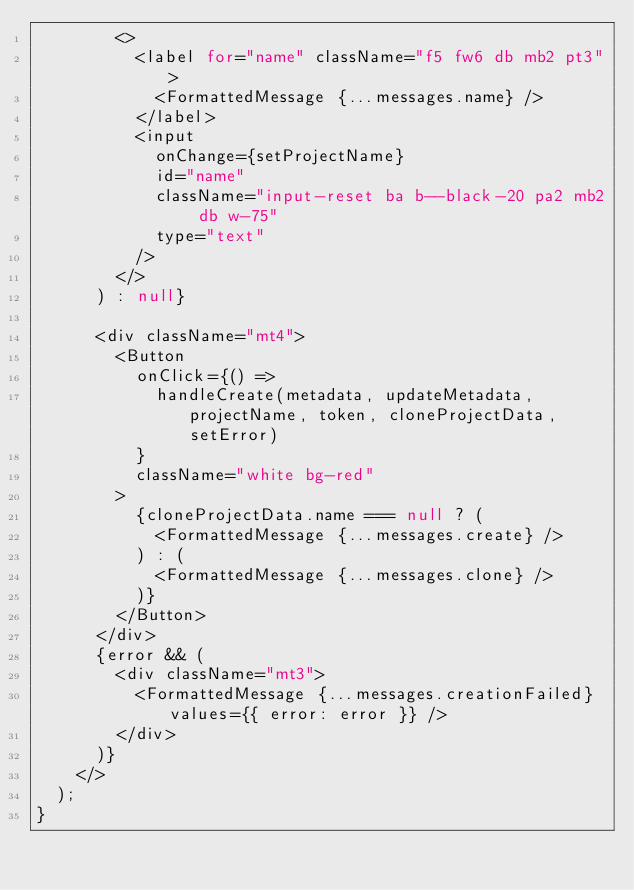<code> <loc_0><loc_0><loc_500><loc_500><_JavaScript_>        <>
          <label for="name" className="f5 fw6 db mb2 pt3">
            <FormattedMessage {...messages.name} />
          </label>
          <input
            onChange={setProjectName}
            id="name"
            className="input-reset ba b--black-20 pa2 mb2 db w-75"
            type="text"
          />
        </>
      ) : null}

      <div className="mt4">
        <Button
          onClick={() =>
            handleCreate(metadata, updateMetadata, projectName, token, cloneProjectData, setError)
          }
          className="white bg-red"
        >
          {cloneProjectData.name === null ? (
            <FormattedMessage {...messages.create} />
          ) : (
            <FormattedMessage {...messages.clone} />
          )}
        </Button>
      </div>
      {error && (
        <div className="mt3">
          <FormattedMessage {...messages.creationFailed} values={{ error: error }} />
        </div>
      )}
    </>
  );
}
</code> 